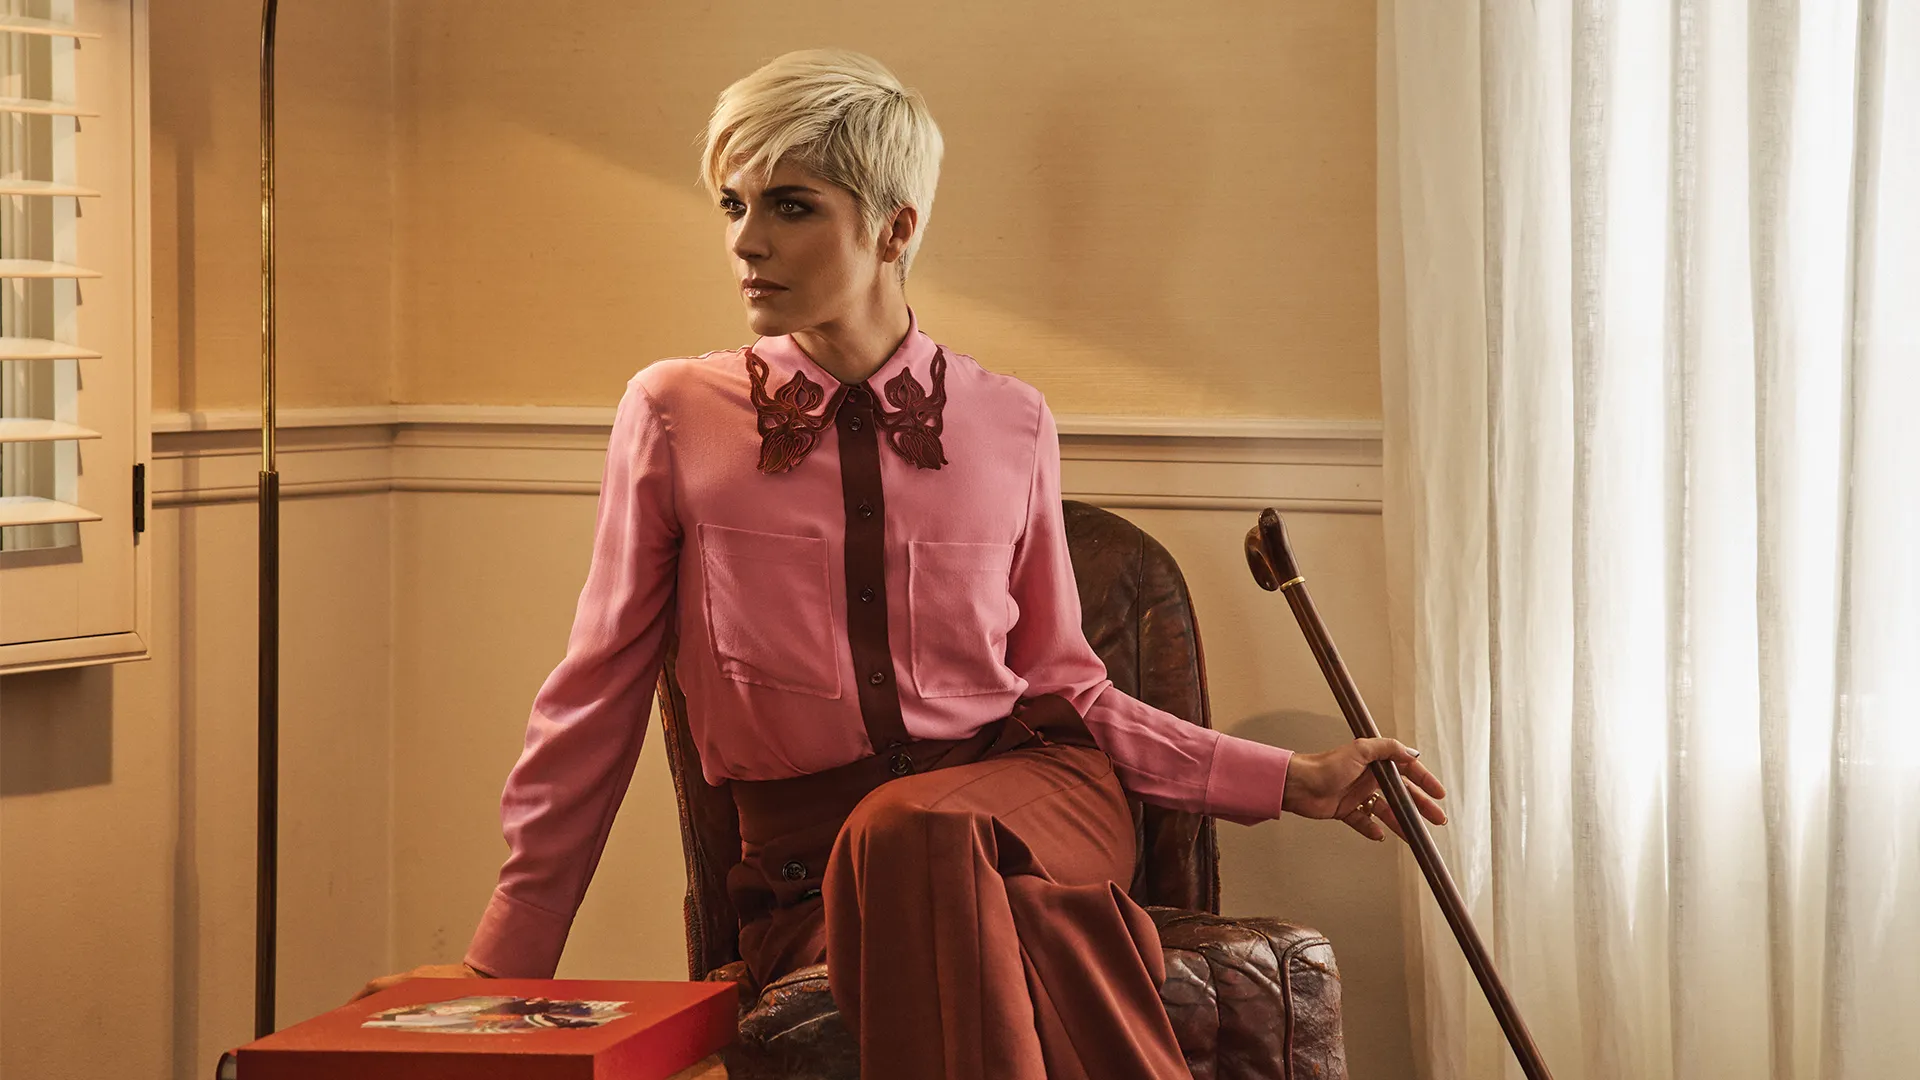Can you describe the mood of the scene in this image? The mood of the scene in this image is one of contemplative introspection. The woman’s serious gaze and the neutral, softly lit background create a calm and focused atmosphere. Her posture, seated comfortably in the leather chair while holding the cane, suggests a sense of resilience and quiet strength. 